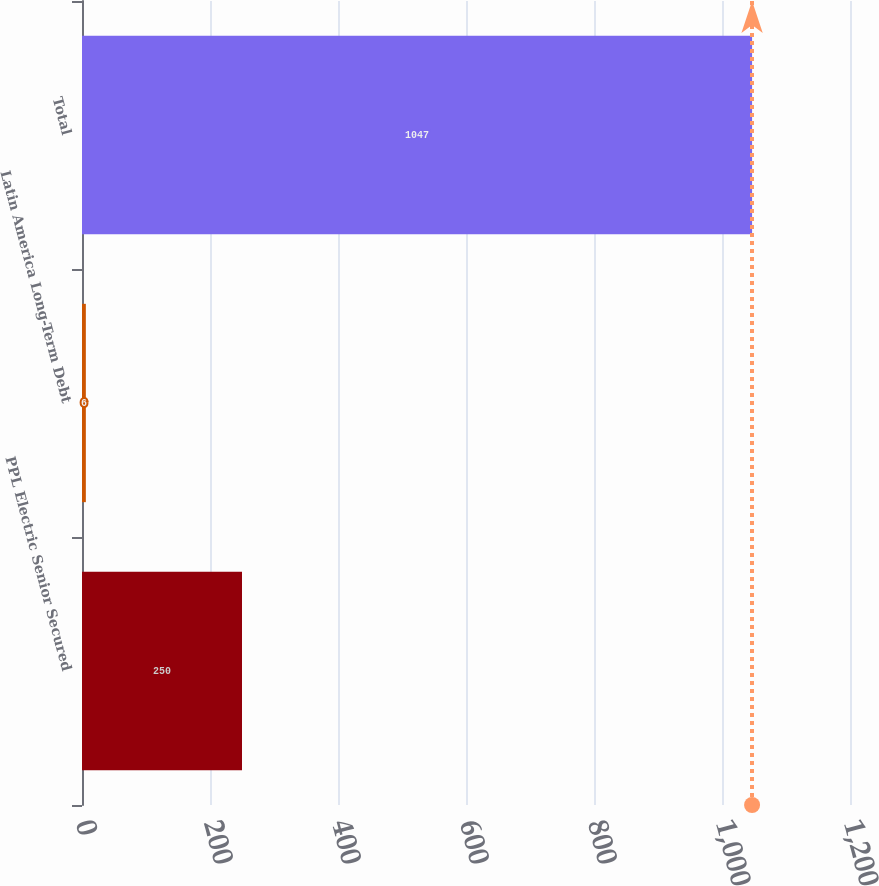Convert chart. <chart><loc_0><loc_0><loc_500><loc_500><bar_chart><fcel>PPL Electric Senior Secured<fcel>Latin America Long-Term Debt<fcel>Total<nl><fcel>250<fcel>6<fcel>1047<nl></chart> 